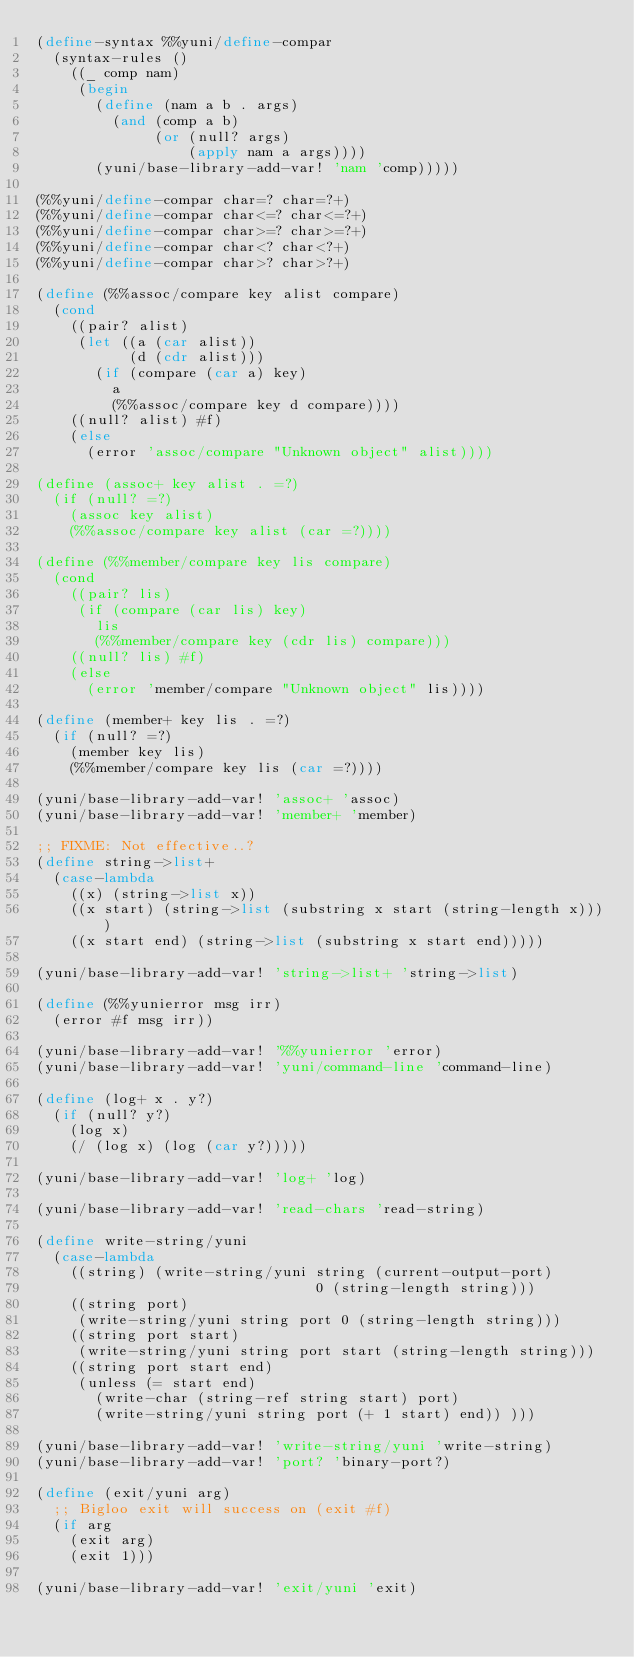Convert code to text. <code><loc_0><loc_0><loc_500><loc_500><_Scheme_>(define-syntax %%yuni/define-compar
  (syntax-rules ()
    ((_ comp nam)
     (begin
       (define (nam a b . args)
         (and (comp a b)
              (or (null? args)
                  (apply nam a args))))
       (yuni/base-library-add-var! 'nam 'comp)))))

(%%yuni/define-compar char=? char=?+)
(%%yuni/define-compar char<=? char<=?+)
(%%yuni/define-compar char>=? char>=?+)
(%%yuni/define-compar char<? char<?+)
(%%yuni/define-compar char>? char>?+)

(define (%%assoc/compare key alist compare)
  (cond
    ((pair? alist)
     (let ((a (car alist))
           (d (cdr alist)))
       (if (compare (car a) key)
         a
         (%%assoc/compare key d compare))))
    ((null? alist) #f)
    (else
      (error 'assoc/compare "Unknown object" alist))))

(define (assoc+ key alist . =?)
  (if (null? =?)
    (assoc key alist)
    (%%assoc/compare key alist (car =?))))

(define (%%member/compare key lis compare)
  (cond
    ((pair? lis)
     (if (compare (car lis) key)
       lis
       (%%member/compare key (cdr lis) compare)))
    ((null? lis) #f)
    (else
      (error 'member/compare "Unknown object" lis))))

(define (member+ key lis . =?)
  (if (null? =?)
    (member key lis)
    (%%member/compare key lis (car =?))))

(yuni/base-library-add-var! 'assoc+ 'assoc)
(yuni/base-library-add-var! 'member+ 'member)

;; FIXME: Not effective..?
(define string->list+
  (case-lambda
    ((x) (string->list x))
    ((x start) (string->list (substring x start (string-length x))))
    ((x start end) (string->list (substring x start end)))))

(yuni/base-library-add-var! 'string->list+ 'string->list)

(define (%%yunierror msg irr)
  (error #f msg irr))

(yuni/base-library-add-var! '%%yunierror 'error)
(yuni/base-library-add-var! 'yuni/command-line 'command-line)

(define (log+ x . y?)
  (if (null? y?)
    (log x)
    (/ (log x) (log (car y?)))))

(yuni/base-library-add-var! 'log+ 'log)

(yuni/base-library-add-var! 'read-chars 'read-string)

(define write-string/yuni
  (case-lambda
    ((string) (write-string/yuni string (current-output-port)
                                 0 (string-length string)))
    ((string port)
     (write-string/yuni string port 0 (string-length string)))
    ((string port start)
     (write-string/yuni string port start (string-length string)))
    ((string port start end)
     (unless (= start end)
       (write-char (string-ref string start) port)
       (write-string/yuni string port (+ 1 start) end)) )))

(yuni/base-library-add-var! 'write-string/yuni 'write-string)
(yuni/base-library-add-var! 'port? 'binary-port?)

(define (exit/yuni arg)
  ;; Bigloo exit will success on (exit #f)
  (if arg
    (exit arg)
    (exit 1)))

(yuni/base-library-add-var! 'exit/yuni 'exit)
</code> 